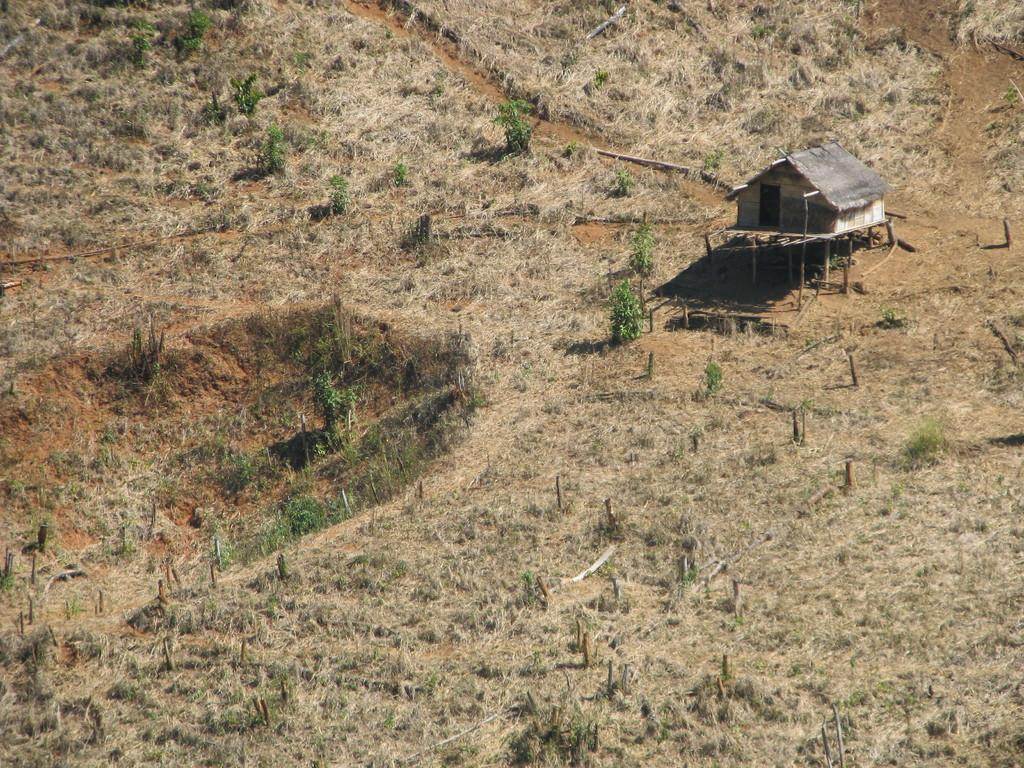What is the main structure in the image? There is a hut in the center of the image. What type of vegetation can be seen in the image? There are plants in the image. What type of ground cover is present in the image? There is grass in the image. What type of crib is visible in the image? There is no crib present in the image. Can you tell me how many rabbits are hopping around in the image? There are no rabbits present in the image. 